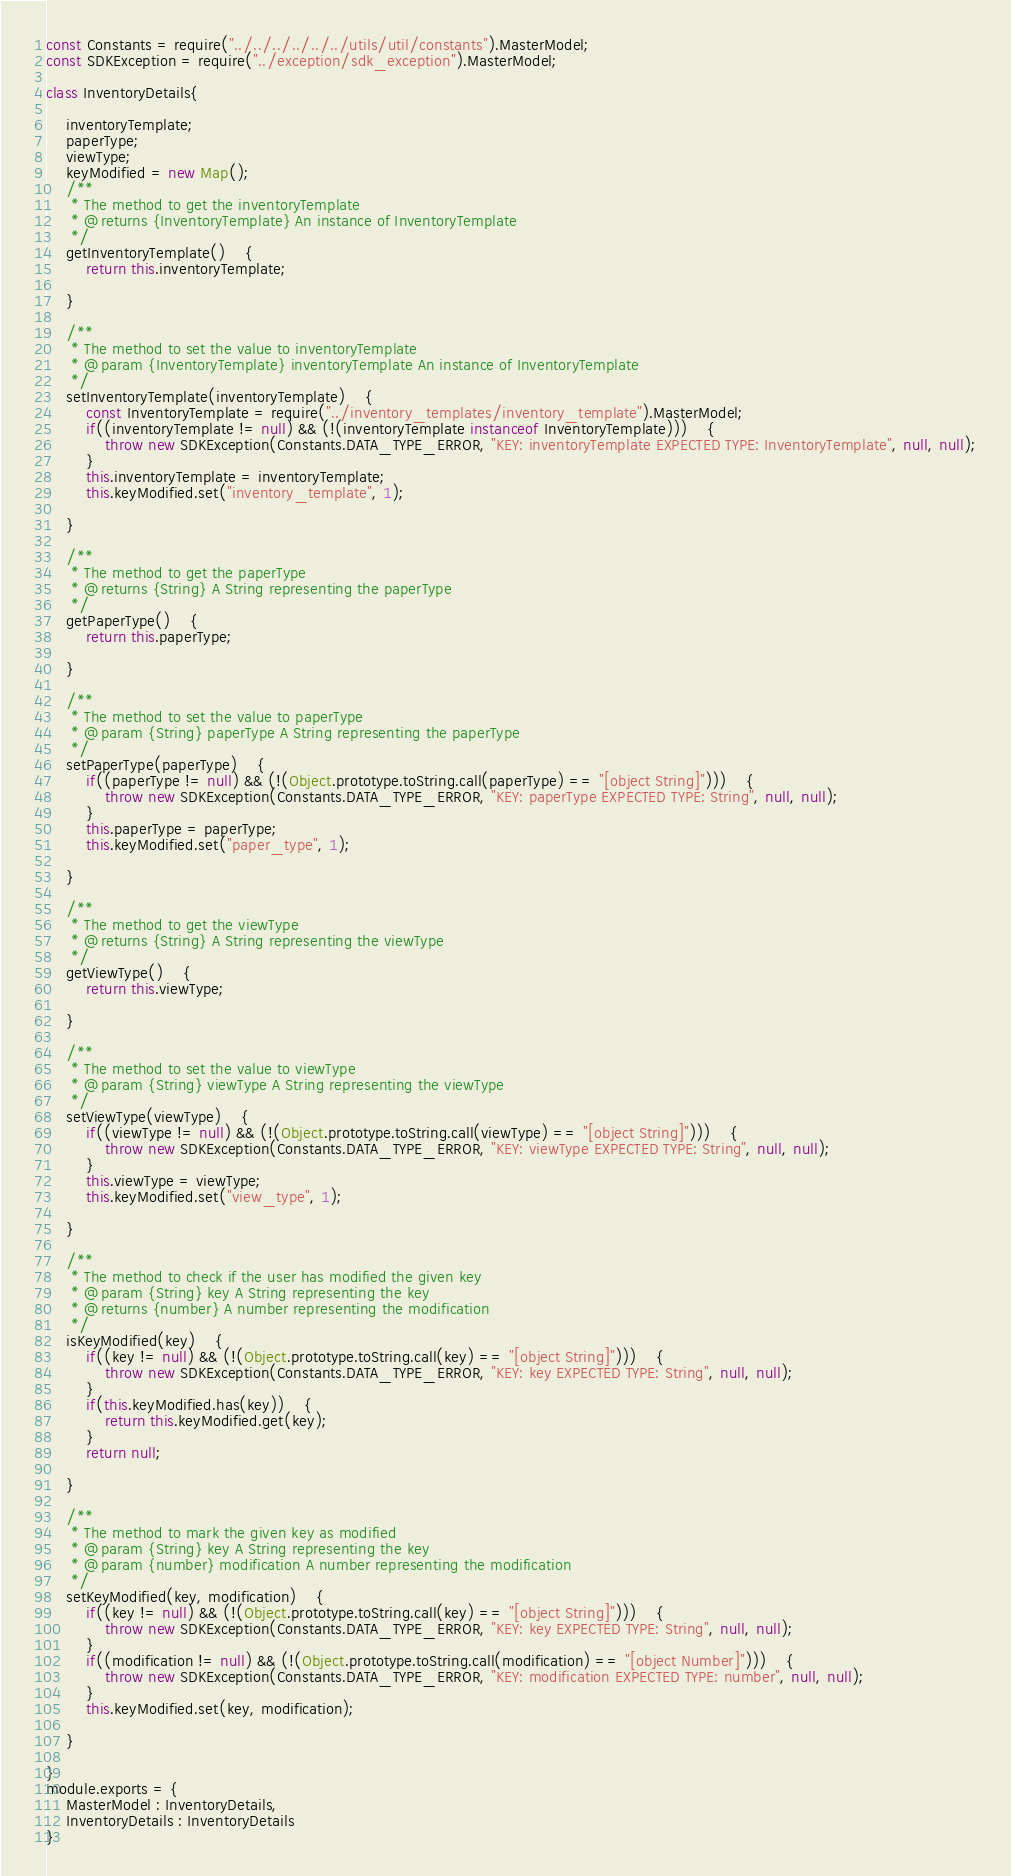<code> <loc_0><loc_0><loc_500><loc_500><_JavaScript_>const Constants = require("../../../../../../utils/util/constants").MasterModel;
const SDKException = require("../exception/sdk_exception").MasterModel;

class InventoryDetails{

	inventoryTemplate;
	paperType;
	viewType;
	keyModified = new Map();
	/**
	 * The method to get the inventoryTemplate
	 * @returns {InventoryTemplate} An instance of InventoryTemplate
	 */
	getInventoryTemplate()	{
		return this.inventoryTemplate;

	}

	/**
	 * The method to set the value to inventoryTemplate
	 * @param {InventoryTemplate} inventoryTemplate An instance of InventoryTemplate
	 */
	setInventoryTemplate(inventoryTemplate)	{
		const InventoryTemplate = require("../inventory_templates/inventory_template").MasterModel;
		if((inventoryTemplate != null) && (!(inventoryTemplate instanceof InventoryTemplate)))	{
			throw new SDKException(Constants.DATA_TYPE_ERROR, "KEY: inventoryTemplate EXPECTED TYPE: InventoryTemplate", null, null);
		}
		this.inventoryTemplate = inventoryTemplate;
		this.keyModified.set("inventory_template", 1);

	}

	/**
	 * The method to get the paperType
	 * @returns {String} A String representing the paperType
	 */
	getPaperType()	{
		return this.paperType;

	}

	/**
	 * The method to set the value to paperType
	 * @param {String} paperType A String representing the paperType
	 */
	setPaperType(paperType)	{
		if((paperType != null) && (!(Object.prototype.toString.call(paperType) == "[object String]")))	{
			throw new SDKException(Constants.DATA_TYPE_ERROR, "KEY: paperType EXPECTED TYPE: String", null, null);
		}
		this.paperType = paperType;
		this.keyModified.set("paper_type", 1);

	}

	/**
	 * The method to get the viewType
	 * @returns {String} A String representing the viewType
	 */
	getViewType()	{
		return this.viewType;

	}

	/**
	 * The method to set the value to viewType
	 * @param {String} viewType A String representing the viewType
	 */
	setViewType(viewType)	{
		if((viewType != null) && (!(Object.prototype.toString.call(viewType) == "[object String]")))	{
			throw new SDKException(Constants.DATA_TYPE_ERROR, "KEY: viewType EXPECTED TYPE: String", null, null);
		}
		this.viewType = viewType;
		this.keyModified.set("view_type", 1);

	}

	/**
	 * The method to check if the user has modified the given key
	 * @param {String} key A String representing the key
	 * @returns {number} A number representing the modification
	 */
	isKeyModified(key)	{
		if((key != null) && (!(Object.prototype.toString.call(key) == "[object String]")))	{
			throw new SDKException(Constants.DATA_TYPE_ERROR, "KEY: key EXPECTED TYPE: String", null, null);
		}
		if(this.keyModified.has(key))	{
			return this.keyModified.get(key);
		}
		return null;

	}

	/**
	 * The method to mark the given key as modified
	 * @param {String} key A String representing the key
	 * @param {number} modification A number representing the modification
	 */
	setKeyModified(key, modification)	{
		if((key != null) && (!(Object.prototype.toString.call(key) == "[object String]")))	{
			throw new SDKException(Constants.DATA_TYPE_ERROR, "KEY: key EXPECTED TYPE: String", null, null);
		}
		if((modification != null) && (!(Object.prototype.toString.call(modification) == "[object Number]")))	{
			throw new SDKException(Constants.DATA_TYPE_ERROR, "KEY: modification EXPECTED TYPE: number", null, null);
		}
		this.keyModified.set(key, modification);

	}

}
module.exports = {
	MasterModel : InventoryDetails,
	InventoryDetails : InventoryDetails
}
</code> 